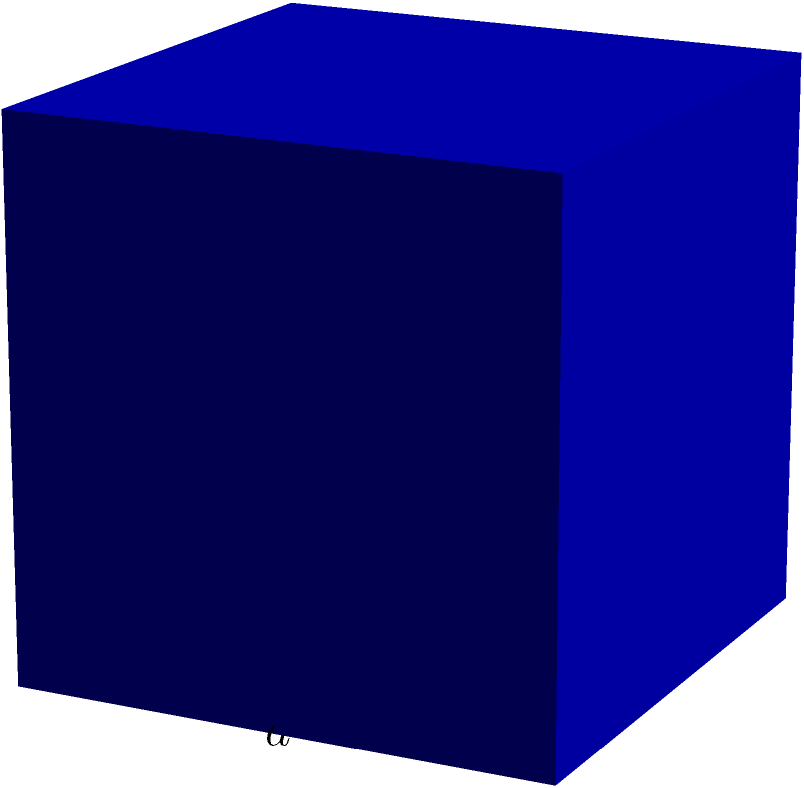As a film historian, you're researching lighting techniques used in classic cinema. You come across a unique cube-shaped lighting fixture from the 1950s. If each edge of this fixture measures $a$ units, what is the total surface area of the fixture? Let's approach this step-by-step:

1) A cube has 6 identical square faces.

2) The area of each face is given by the square of its side length. In this case, each face has an area of $a^2$.

3) To find the total surface area, we need to multiply the area of one face by the number of faces:

   Surface Area = $6 \times a^2$

4) Therefore, the total surface area of the cube-shaped lighting fixture is $6a^2$ square units.

This calculation would be crucial for understanding the light output and heat dissipation of the fixture, factors that would have been important considerations for gaffers working with these lights on film sets in the 1950s.
Answer: $6a^2$ square units 